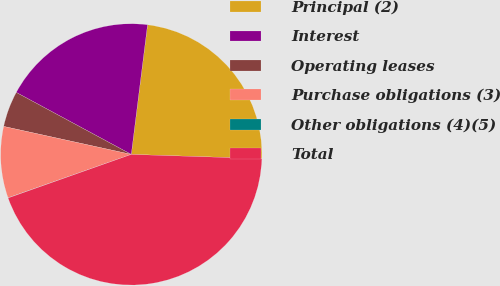Convert chart to OTSL. <chart><loc_0><loc_0><loc_500><loc_500><pie_chart><fcel>Principal (2)<fcel>Interest<fcel>Operating leases<fcel>Purchase obligations (3)<fcel>Other obligations (4)(5)<fcel>Total<nl><fcel>23.53%<fcel>19.12%<fcel>4.43%<fcel>8.83%<fcel>0.02%<fcel>44.08%<nl></chart> 